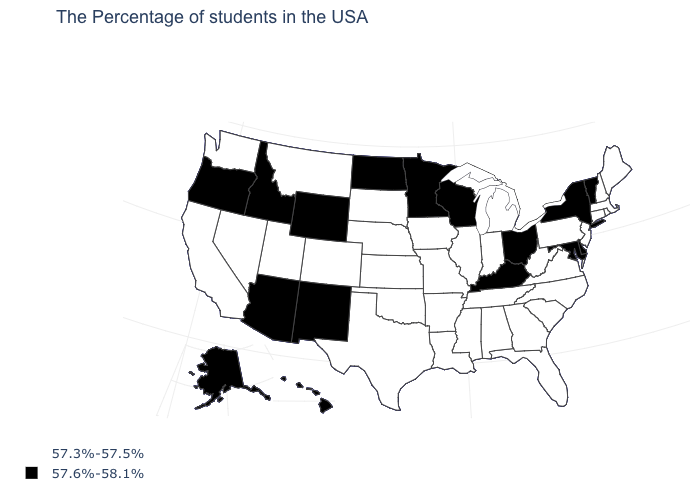How many symbols are there in the legend?
Quick response, please. 2. What is the value of Delaware?
Answer briefly. 57.6%-58.1%. How many symbols are there in the legend?
Write a very short answer. 2. What is the lowest value in the USA?
Give a very brief answer. 57.3%-57.5%. Which states have the highest value in the USA?
Be succinct. Vermont, New York, Delaware, Maryland, Ohio, Kentucky, Wisconsin, Minnesota, North Dakota, Wyoming, New Mexico, Arizona, Idaho, Oregon, Alaska, Hawaii. What is the value of North Dakota?
Short answer required. 57.6%-58.1%. What is the value of Texas?
Quick response, please. 57.3%-57.5%. Name the states that have a value in the range 57.6%-58.1%?
Write a very short answer. Vermont, New York, Delaware, Maryland, Ohio, Kentucky, Wisconsin, Minnesota, North Dakota, Wyoming, New Mexico, Arizona, Idaho, Oregon, Alaska, Hawaii. Among the states that border South Dakota , does North Dakota have the highest value?
Keep it brief. Yes. Name the states that have a value in the range 57.6%-58.1%?
Write a very short answer. Vermont, New York, Delaware, Maryland, Ohio, Kentucky, Wisconsin, Minnesota, North Dakota, Wyoming, New Mexico, Arizona, Idaho, Oregon, Alaska, Hawaii. Name the states that have a value in the range 57.6%-58.1%?
Answer briefly. Vermont, New York, Delaware, Maryland, Ohio, Kentucky, Wisconsin, Minnesota, North Dakota, Wyoming, New Mexico, Arizona, Idaho, Oregon, Alaska, Hawaii. Among the states that border South Dakota , does Nebraska have the lowest value?
Be succinct. Yes. Which states hav the highest value in the West?
Concise answer only. Wyoming, New Mexico, Arizona, Idaho, Oregon, Alaska, Hawaii. Name the states that have a value in the range 57.3%-57.5%?
Answer briefly. Maine, Massachusetts, Rhode Island, New Hampshire, Connecticut, New Jersey, Pennsylvania, Virginia, North Carolina, South Carolina, West Virginia, Florida, Georgia, Michigan, Indiana, Alabama, Tennessee, Illinois, Mississippi, Louisiana, Missouri, Arkansas, Iowa, Kansas, Nebraska, Oklahoma, Texas, South Dakota, Colorado, Utah, Montana, Nevada, California, Washington. What is the lowest value in states that border Missouri?
Be succinct. 57.3%-57.5%. 